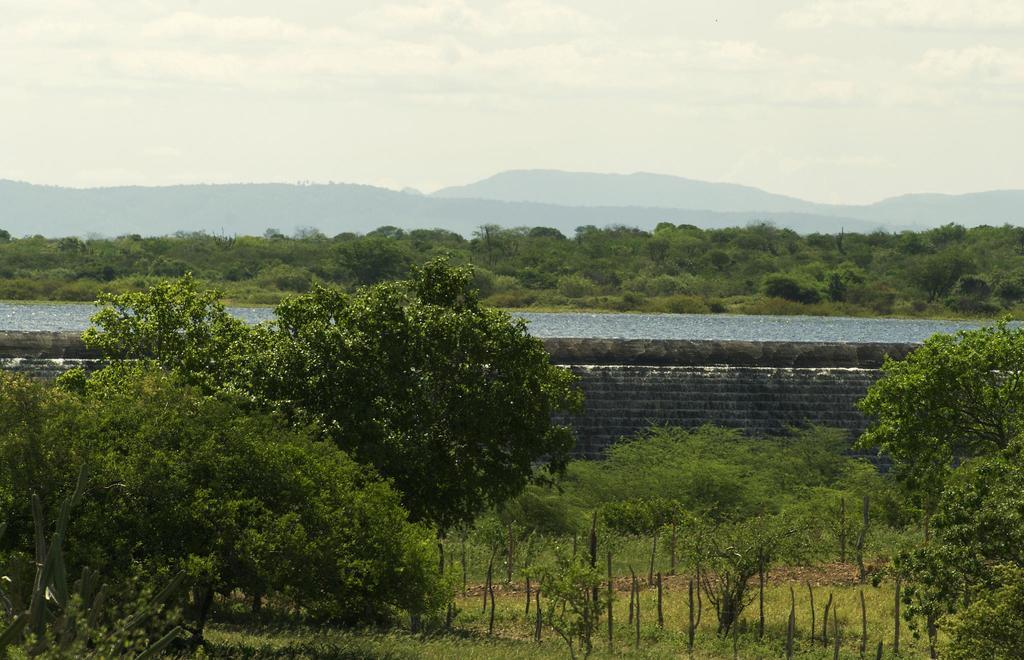What type of vegetation is present in the image? There are trees of green color in the image. What natural element can be seen besides the trees? There is water visible in the image. What part of the natural environment is visible in the image? The sky is visible in the image. Where is the crate located in the image? There is no crate present in the image. What type of emotion is being expressed by the trees in the image? Trees do not express emotions, so this question cannot be answered definitively. 